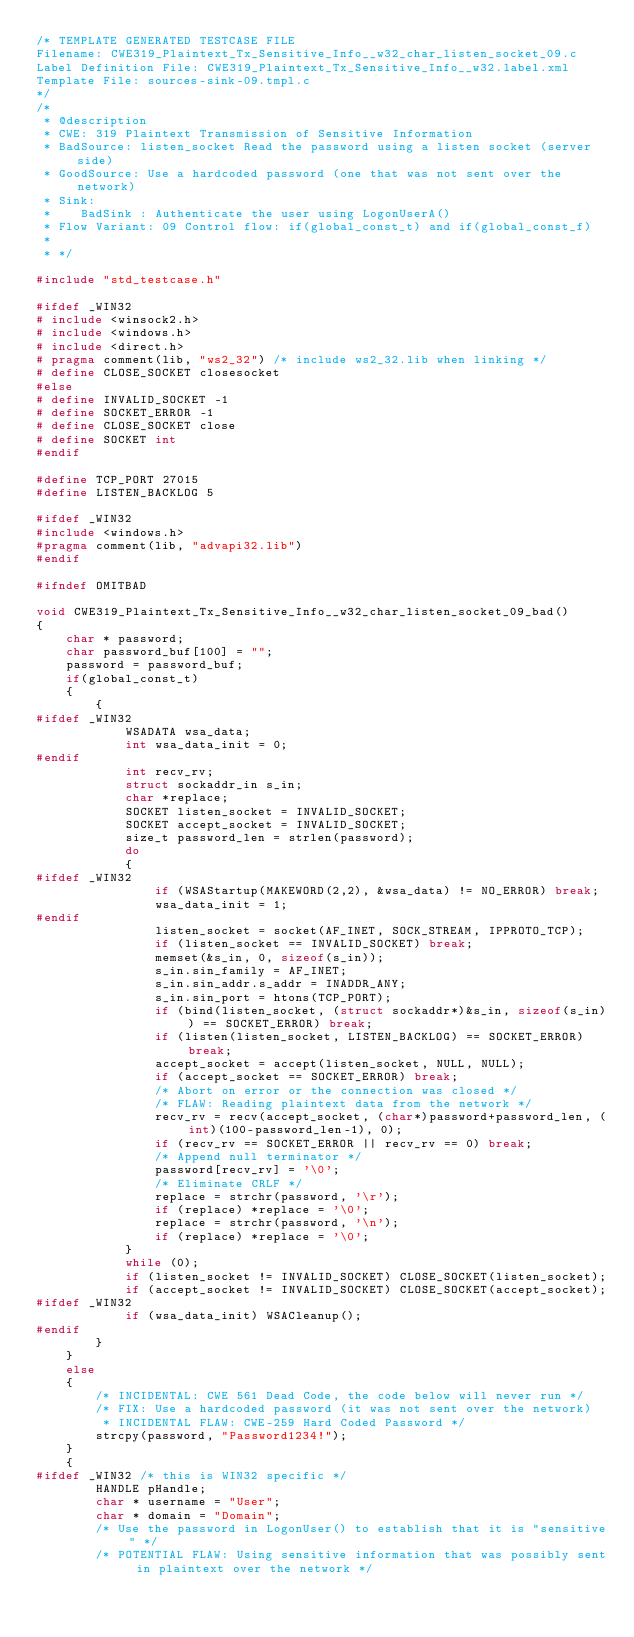<code> <loc_0><loc_0><loc_500><loc_500><_C_>/* TEMPLATE GENERATED TESTCASE FILE
Filename: CWE319_Plaintext_Tx_Sensitive_Info__w32_char_listen_socket_09.c
Label Definition File: CWE319_Plaintext_Tx_Sensitive_Info__w32.label.xml
Template File: sources-sink-09.tmpl.c
*/
/*
 * @description
 * CWE: 319 Plaintext Transmission of Sensitive Information
 * BadSource: listen_socket Read the password using a listen socket (server side)
 * GoodSource: Use a hardcoded password (one that was not sent over the network)
 * Sink:
 *    BadSink : Authenticate the user using LogonUserA()
 * Flow Variant: 09 Control flow: if(global_const_t) and if(global_const_f)
 *
 * */

#include "std_testcase.h"

#ifdef _WIN32
# include <winsock2.h>
# include <windows.h>
# include <direct.h>
# pragma comment(lib, "ws2_32") /* include ws2_32.lib when linking */
# define CLOSE_SOCKET closesocket
#else
# define INVALID_SOCKET -1
# define SOCKET_ERROR -1
# define CLOSE_SOCKET close
# define SOCKET int
#endif

#define TCP_PORT 27015
#define LISTEN_BACKLOG 5

#ifdef _WIN32
#include <windows.h>
#pragma comment(lib, "advapi32.lib")
#endif

#ifndef OMITBAD

void CWE319_Plaintext_Tx_Sensitive_Info__w32_char_listen_socket_09_bad()
{
    char * password;
    char password_buf[100] = "";
    password = password_buf;
    if(global_const_t)
    {
        {
#ifdef _WIN32
            WSADATA wsa_data;
            int wsa_data_init = 0;
#endif
            int recv_rv;
            struct sockaddr_in s_in;
            char *replace;
            SOCKET listen_socket = INVALID_SOCKET;
            SOCKET accept_socket = INVALID_SOCKET;
            size_t password_len = strlen(password);
            do
            {
#ifdef _WIN32
                if (WSAStartup(MAKEWORD(2,2), &wsa_data) != NO_ERROR) break;
                wsa_data_init = 1;
#endif
                listen_socket = socket(AF_INET, SOCK_STREAM, IPPROTO_TCP);
                if (listen_socket == INVALID_SOCKET) break;
                memset(&s_in, 0, sizeof(s_in));
                s_in.sin_family = AF_INET;
                s_in.sin_addr.s_addr = INADDR_ANY;
                s_in.sin_port = htons(TCP_PORT);
                if (bind(listen_socket, (struct sockaddr*)&s_in, sizeof(s_in)) == SOCKET_ERROR) break;
                if (listen(listen_socket, LISTEN_BACKLOG) == SOCKET_ERROR) break;
                accept_socket = accept(listen_socket, NULL, NULL);
                if (accept_socket == SOCKET_ERROR) break;
                /* Abort on error or the connection was closed */
                /* FLAW: Reading plaintext data from the network */
                recv_rv = recv(accept_socket, (char*)password+password_len, (int)(100-password_len-1), 0);
                if (recv_rv == SOCKET_ERROR || recv_rv == 0) break;
                /* Append null terminator */
                password[recv_rv] = '\0';
                /* Eliminate CRLF */
                replace = strchr(password, '\r');
                if (replace) *replace = '\0';
                replace = strchr(password, '\n');
                if (replace) *replace = '\0';
            }
            while (0);
            if (listen_socket != INVALID_SOCKET) CLOSE_SOCKET(listen_socket);
            if (accept_socket != INVALID_SOCKET) CLOSE_SOCKET(accept_socket);
#ifdef _WIN32
            if (wsa_data_init) WSACleanup();
#endif
        }
    }
    else
    {
        /* INCIDENTAL: CWE 561 Dead Code, the code below will never run */
        /* FIX: Use a hardcoded password (it was not sent over the network)
         * INCIDENTAL FLAW: CWE-259 Hard Coded Password */
        strcpy(password, "Password1234!");
    }
    {
#ifdef _WIN32 /* this is WIN32 specific */
        HANDLE pHandle;
        char * username = "User";
        char * domain = "Domain";
        /* Use the password in LogonUser() to establish that it is "sensitive" */
        /* POTENTIAL FLAW: Using sensitive information that was possibly sent in plaintext over the network */</code> 